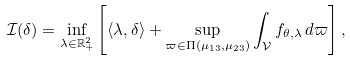<formula> <loc_0><loc_0><loc_500><loc_500>\mathcal { I } ( \delta ) = \inf _ { \lambda \in \mathbb { R } _ { + } ^ { 2 } } \left [ \langle \lambda , \delta \rangle + \sup _ { \varpi \in \Pi ( \mu _ { 1 3 } , \mu _ { 2 3 } ) } \int _ { \mathcal { V } } f _ { \theta , \lambda } \, d \varpi \right ] ,</formula> 